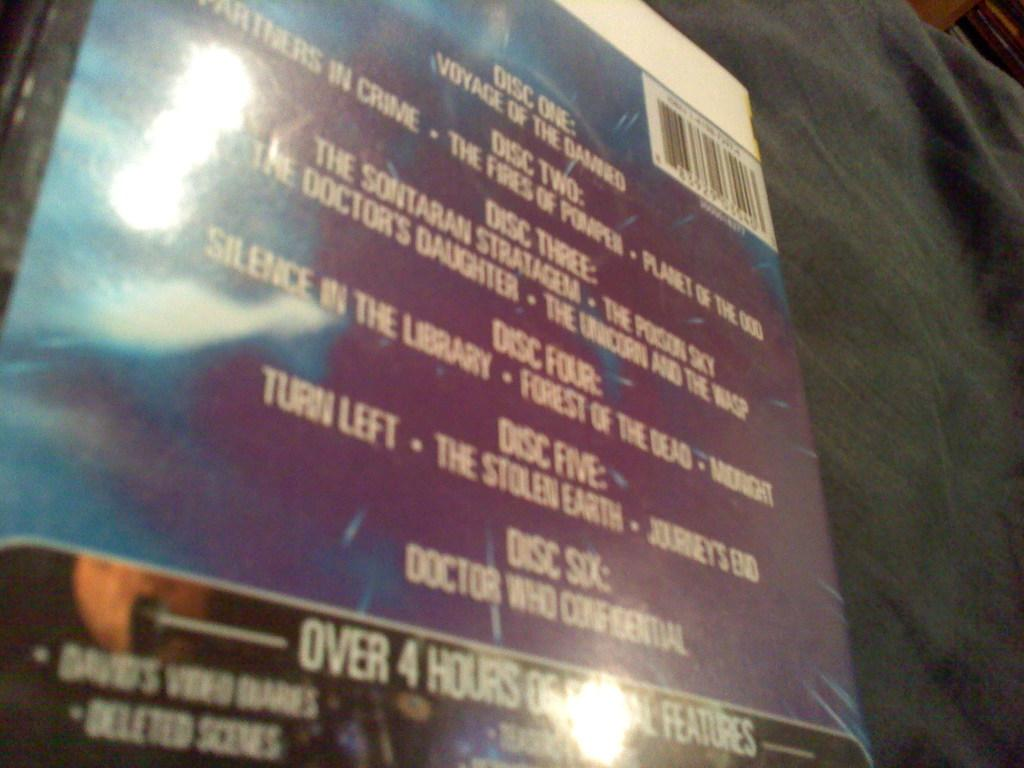<image>
Render a clear and concise summary of the photo. The label for a six disk set of recordings with over four hours of features. 